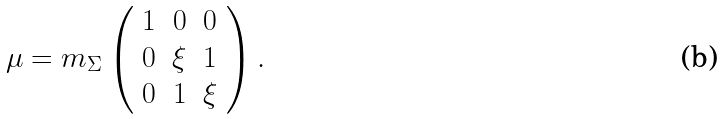Convert formula to latex. <formula><loc_0><loc_0><loc_500><loc_500>\mu = m _ { \Sigma } \left ( \begin{array} { c c c } 1 & 0 & 0 \\ 0 & \xi & 1 \\ 0 & 1 & \xi \end{array} \right ) .</formula> 